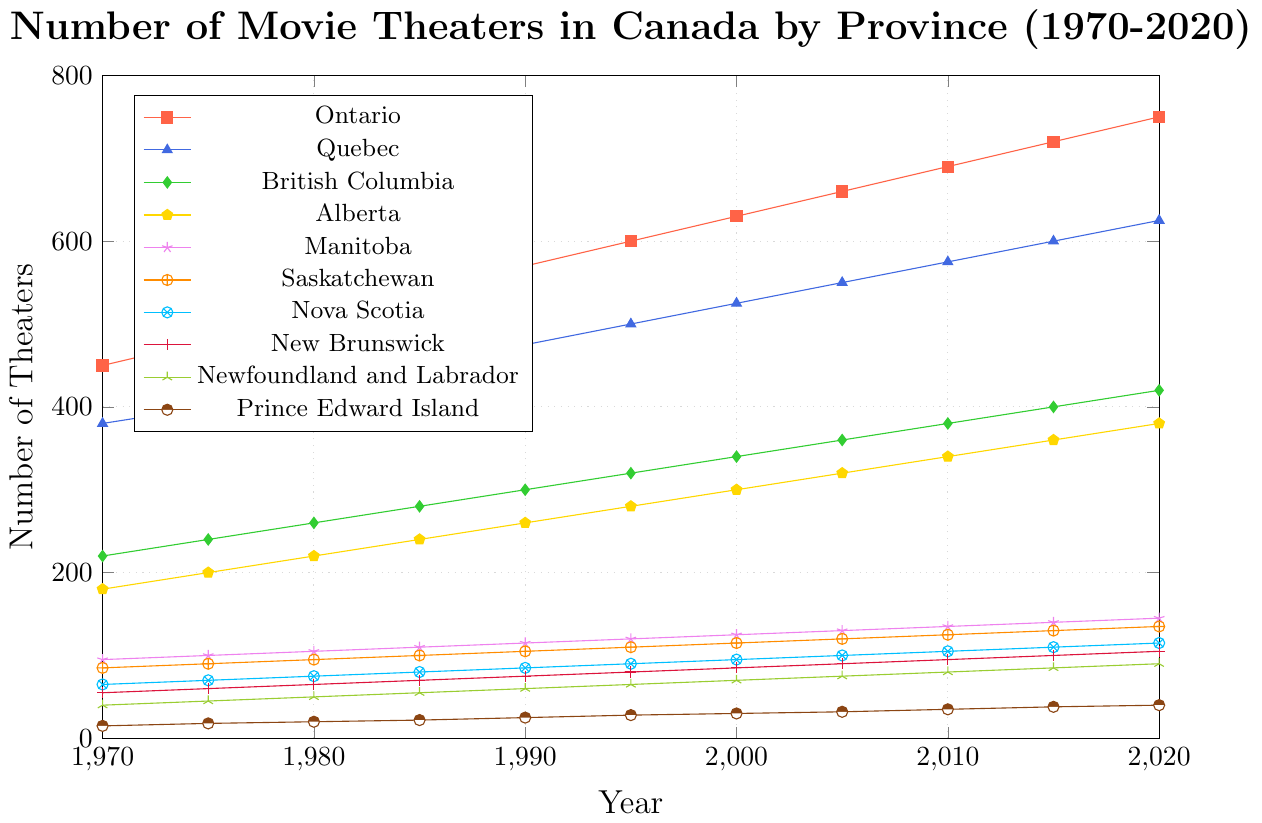What is the general trend of the number of movie theaters in Ontario from 1970 to 2020? The number of movie theaters in Ontario consistently increases over the 50-year period.
Answer: Increasing Which province had more movie theaters in 1980, Quebec or British Columbia? In 1980, Quebec had 425 theaters, while British Columbia had 260 theaters.
Answer: Quebec What is the difference in the number of theaters between Ontario and Prince Edward Island in 2020? In 2020, Ontario had 750 theaters, and Prince Edward Island had 40 theaters. The difference is 750 - 40.
Answer: 710 Which provinces had exactly 100 theaters in 2015? According to the figure, Manitoba and New Brunswick had exactly 100 theaters in 2015.
Answer: Manitoba, New Brunswick What was the average number of theaters in Nova Scotia over the entire 50-year period? Sum the data points for Nova Scotia (65 + 70 + 75 + 80 + 85 + 90 + 95 + 100 + 105 + 110 + 115) = 990. Divide by the number of data points, which is 11.
Answer: 90 Which province showed the least growth in the number of theaters from 1970 to 2020? Prince Edward Island had the least growth, increasing only from 15 theaters in 1970 to 40 theaters in 2020.
Answer: Prince Edward Island During which decade did Alberta experience the most significant growth in the number of theaters? By comparing the differences between decades, Alberta saw the most significant growth between 1970 (180 theaters) and 1980 (220 theaters), which is a growth of 40 theaters.
Answer: 1970-1980 What is the sum of theaters in Newfoundland and Labrador and Prince Edward Island in 2000? In 2000, Newfoundland and Labrador had 70 theaters, and Prince Edward Island had 30 theaters. Their sum is 70 + 30.
Answer: 100 Which province had a faster-growing number of theaters between 1970 and 2020, Saskatchewan or Nova Scotia? Saskatchewan grew from 85 to 135 theaters (50 theaters), while Nova Scotia grew from 65 to 115 theaters (50 theaters). Both provinces had the same growth.
Answer: Equal growth Compare the growth rate of theaters in Quebec and Manitoba from 1970 to 2020. Which province had a higher growth rate? Quebec grew from 380 to 625 theaters (245 theaters), and Manitoba grew from 95 to 145 theaters (50 theaters). The growth rate for Quebec is (245/380), and for Manitoba, it is (50/95). Quebec has a higher growth rate.
Answer: Quebec 